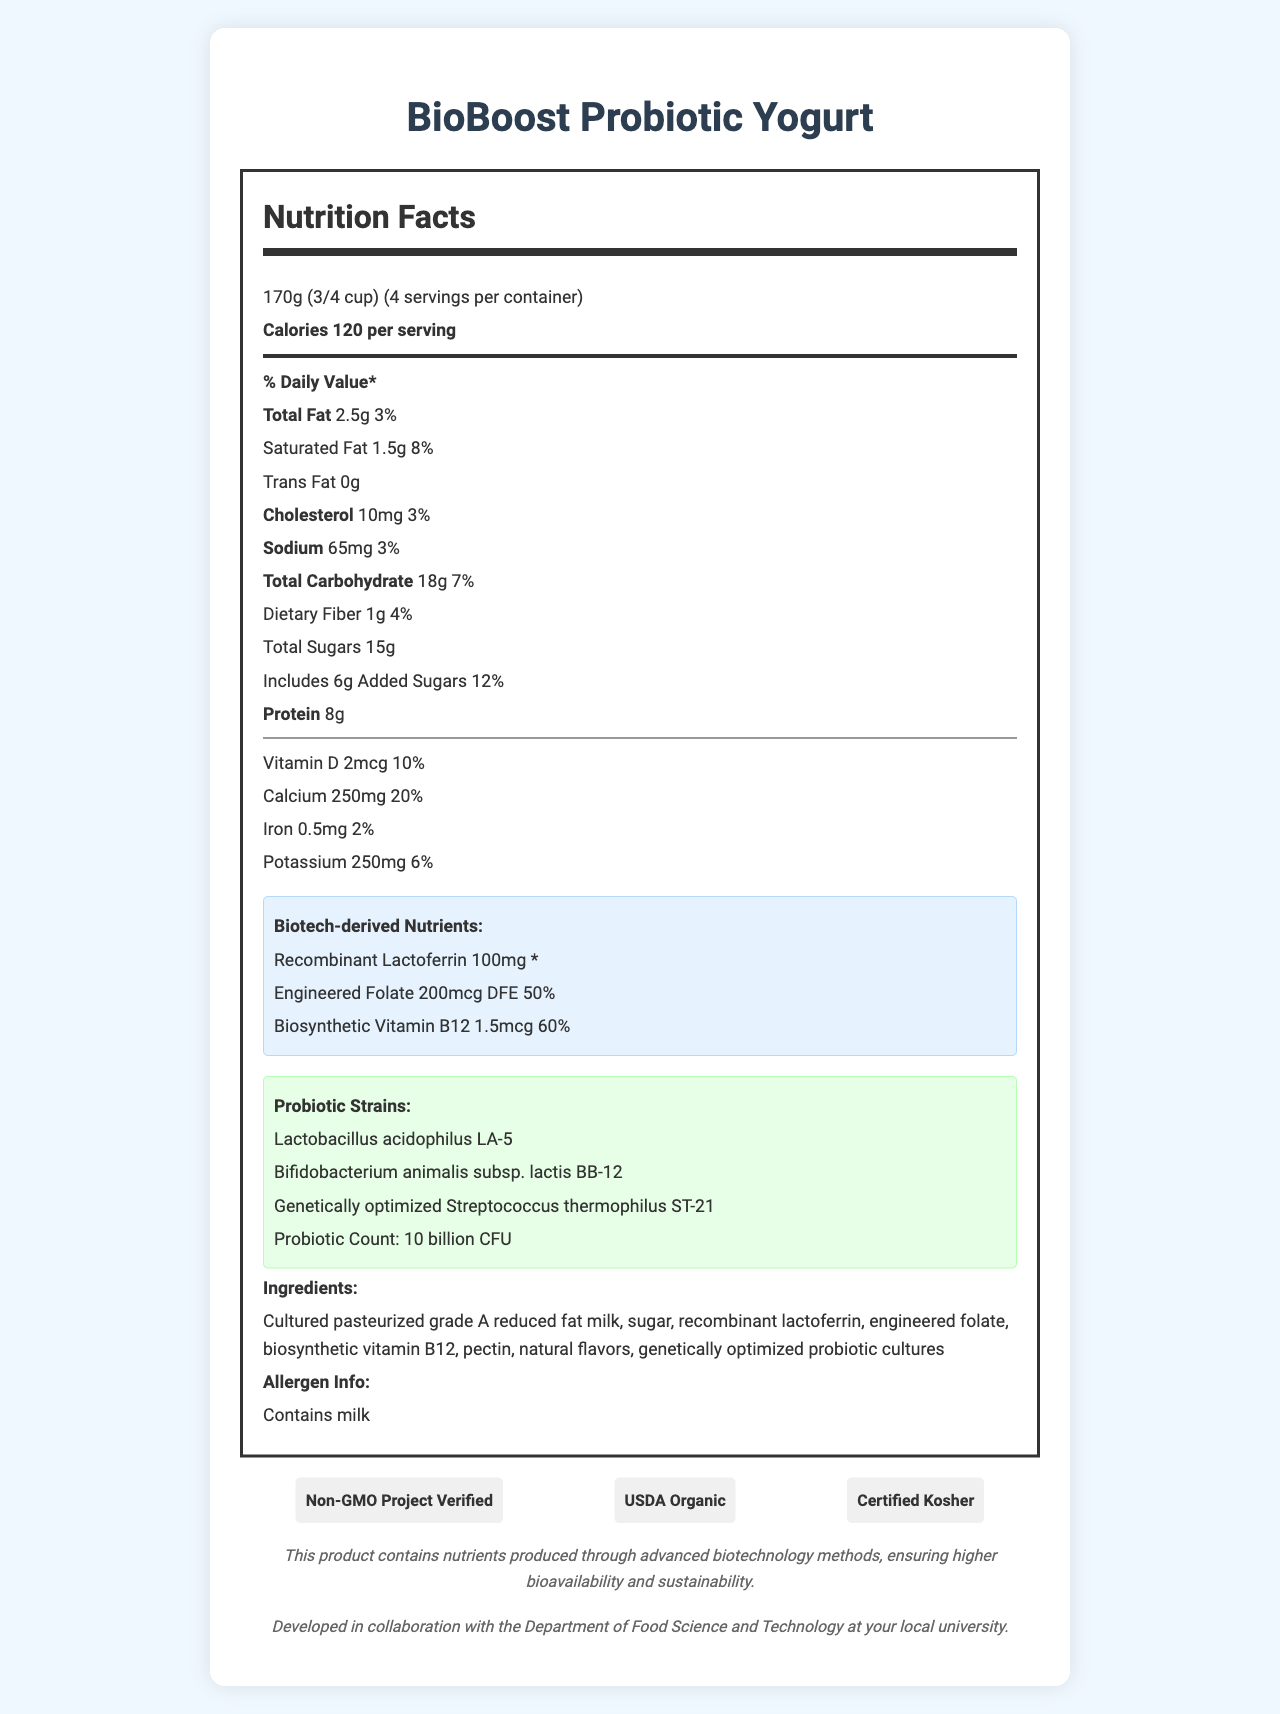what is the serving size of BioBoost Probiotic Yogurt? The document states that the serving size of BioBoost Probiotic Yogurt is 170g, which is equivalent to 3/4 cup.
Answer: 170g (3/4 cup) how many calories are there per serving? The Nutrition Facts label specifies that there are 120 calories per serving.
Answer: 120 what is the total fat content per serving? The label indicates that the total fat content per serving is 2.5g.
Answer: 2.5g what percent of the daily value is the total fat per serving? The label provides that the total fat content per serving is 3% of the daily value.
Answer: 3% list one of the probiotic strains present in the yogurt. Lactobacillus acidophilus LA-5 is one of the probiotic strains listed in the document.
Answer: Lactobacillus acidophilus LA-5 what is the percentage of daily value for calcium in BioBoost Probiotic Yogurt? The document indicates that the yogurt provides 20% of the daily value for calcium.
Answer: 20% what is the amount of engineered folate per serving? A. 100mg B. 200mcg DFE C. 1.5mcg The document specifies that each serving contains 200mcg DFE of engineered folate.
Answer: B which certification does the yogurt NOT have? A. Non-GMO Project Verified B. Certified Gluten-Free C. USDA Organic D. Certified Kosher The document lists the certifications as Non-GMO Project Verified, USDA Organic, and Certified Kosher. Certified Gluten-Free is not among the certifications.
Answer: B does BioBoost Probiotic Yogurt contain added sugars? The label mentions that the yogurt includes 6g of added sugars, accounting for 12% of the daily value.
Answer: Yes summarize the main idea of the document. The explanation involves an overview of the nutritional specifics, the inclusion of biotech-derived nutrients and probiotic strains, and the certifications received by the product, reflecting its nutritional value and advanced formulation.
Answer: The document describes the nutritional and compositional details of BioBoost Probiotic Yogurt, including information on serving size, calories, fat content, biotechnology-derived nutrients, probiotic strains, certifications, and more, highlighting its advanced biotechnology methods for nutrients and various certifications. what is the exact strain of Streptococcus in this product? The document specifically names "Genetically optimized Streptococcus thermophilus ST-21" as one of the probiotic strains.
Answer: Genetically optimized Streptococcus thermophilus ST-21 who developed the BioBoost Probiotic Yogurt? A. FoodTech Inc. B. BioBoost Corp. C. Department of Food Science and Technology at the local university D. Healthy Foods Ltd. The document states that the product was developed in collaboration with the Department of Food Science and Technology at the local university.
Answer: C is the yogurt gluten-free? The document doesn't provide any information about the yogurt being gluten-free.
Answer: Cannot be determined what makes the nutrients 'biotech-derived'? The document highlights that the product contains nutrients produced through advanced biotechnology methods, ensuring higher bioavailability and sustainability.
Answer: Advanced biotechnology methods 